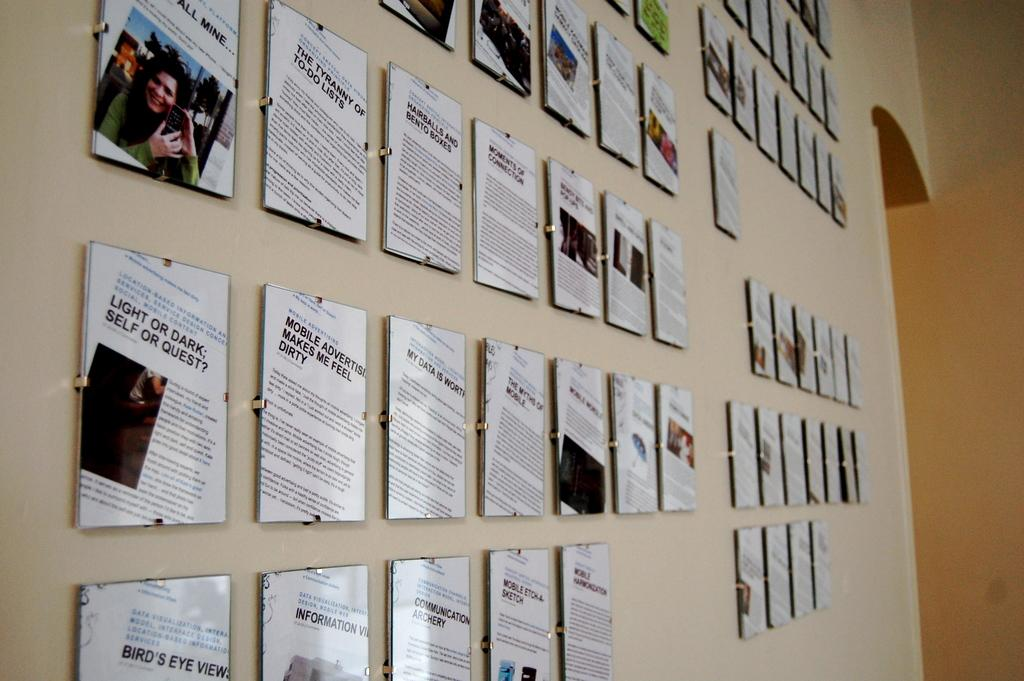<image>
Offer a succinct explanation of the picture presented. Plaques line a wall with different news articles such as "Light or Dark: Self or Quest?" 